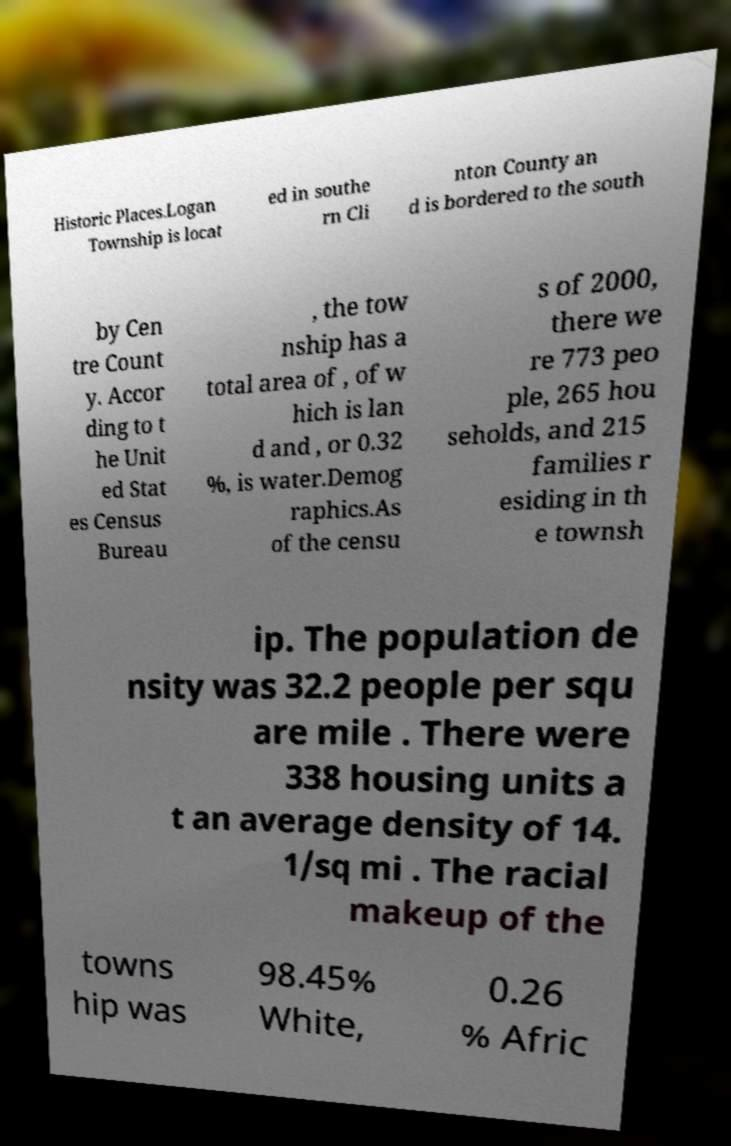There's text embedded in this image that I need extracted. Can you transcribe it verbatim? Historic Places.Logan Township is locat ed in southe rn Cli nton County an d is bordered to the south by Cen tre Count y. Accor ding to t he Unit ed Stat es Census Bureau , the tow nship has a total area of , of w hich is lan d and , or 0.32 %, is water.Demog raphics.As of the censu s of 2000, there we re 773 peo ple, 265 hou seholds, and 215 families r esiding in th e townsh ip. The population de nsity was 32.2 people per squ are mile . There were 338 housing units a t an average density of 14. 1/sq mi . The racial makeup of the towns hip was 98.45% White, 0.26 % Afric 